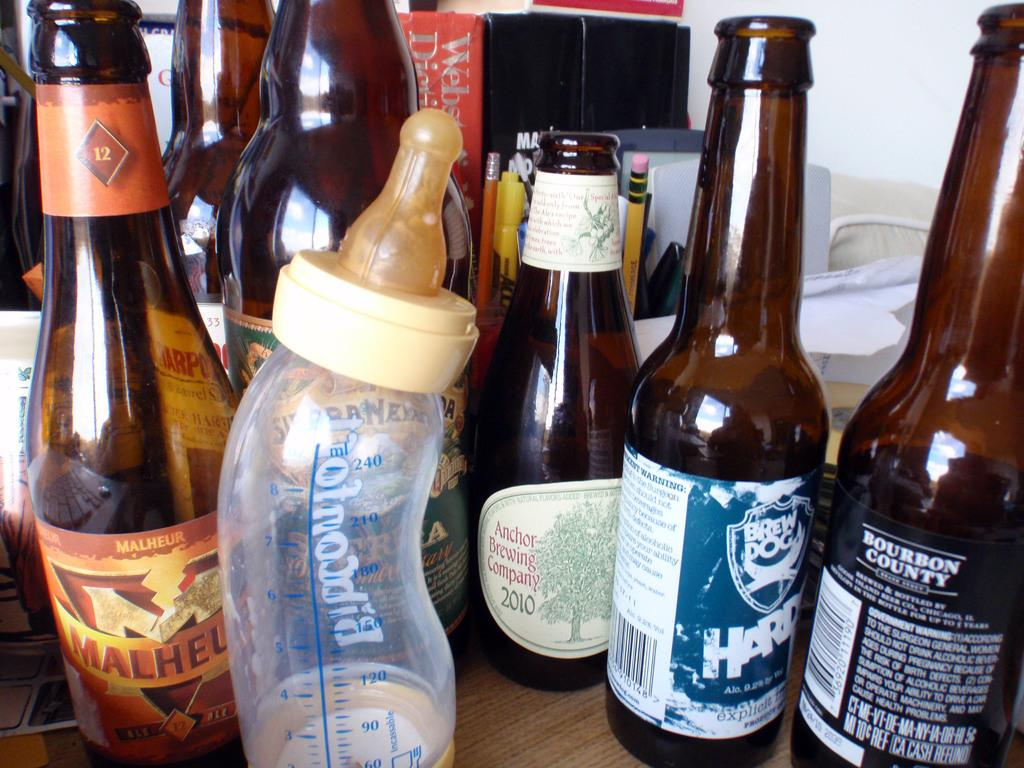<image>
Share a concise interpretation of the image provided. A bottle of Malheur beer sits next to a baby bottle on a table 